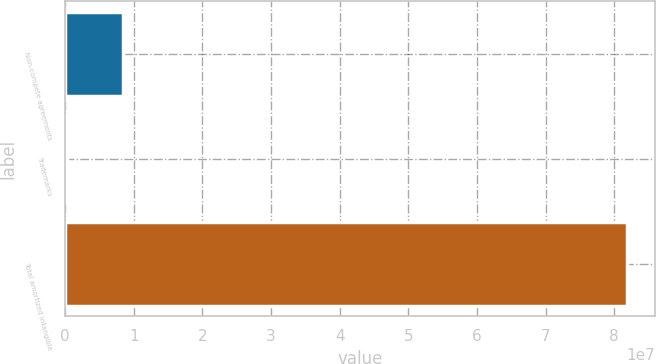Convert chart. <chart><loc_0><loc_0><loc_500><loc_500><bar_chart><fcel>Non-compete agreements<fcel>Trademarks<fcel>Total amortized intangible<nl><fcel>8.4369e+06<fcel>280000<fcel>8.1849e+07<nl></chart> 